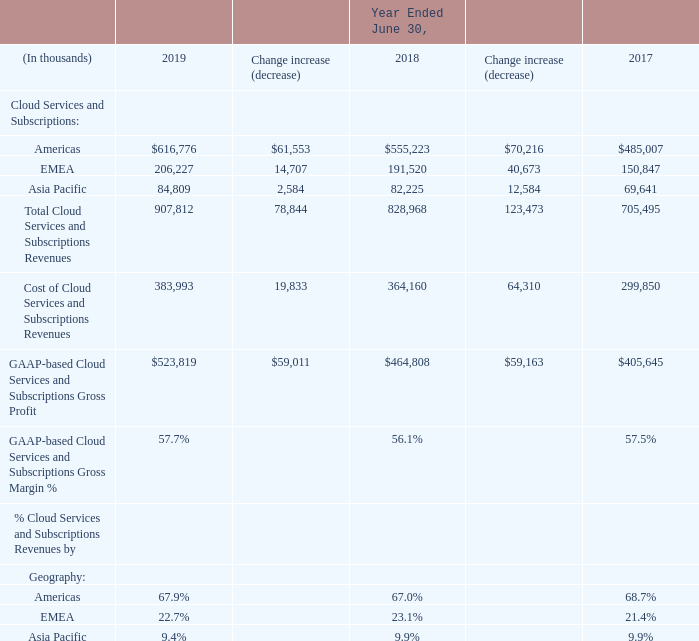2) Cloud Services and Subscriptions:
Cloud services and subscriptions revenues are from hosting arrangements where in connection with the licensing of software, the end user doesn’t take possession of the software, as well as from end-to-end fully outsourced business-to-business (B2B) integration solutions to our customers (collectively referred to as cloud arrangements). The software application resides on our hardware or that of a third party, and the customer accesses and uses the software on an as-needed basis via an identified line. Our cloud arrangements can be broadly categorized as "platform as a service" (PaaS), "software as a service" (SaaS), cloud subscriptions and managed services.
Cost of Cloud services and subscriptions revenues is comprised primarily of third party network usage fees, maintenance of in-house data hardware centers, technical support personnel-related costs, and some third party royalty costs.
Cloud services and subscriptions revenues increased by $78.8 million or 9.5% during the year ended June 30, 2019 as compared to the prior fiscal year; up 10.8% after factoring the impact of $10.8 million of foreign exchange rate changes. Geographically, the overall change was attributable to an increase in Americas of $61.6 million, an increase in EMEA of $14.7 million, and an increase in Asia Pacific of $2.6 million.
The number of Cloud services deals greater than $1.0 million that closed during Fiscal 2019 was 46 deals, consistent with that in Fiscal 2018.
Cost of Cloud services and subscriptions revenues increased by $19.8 million during the year ended June 30, 2019 as compared to the prior fiscal year, due to an increase in labour-related costs of approximately $19.1 million and an increase in third party network usage fees of $1.3 million. These were partially offset by a decrease in other miscellaneous costs of $0.6 million. The increase in labour-related costs was primarily due to increased headcount from recent acquisitions.
Overall, the gross margin percentage on Cloud services and subscriptions revenues increased to approximately 58% from approximately 56%.
For illustrative purposes only, had we accounted for revenues under proforma Topic 605, Cloud services and subscriptions revenues would have been $901.5 million for the year ended June 30, 2019, which would have been higher by approximately $72.5 million or 8.7% as compared to the prior fiscal year; and would have been up 10.1% after factoring the impact of $11.0 million of foreign exchange rate changes. Geographically, the overall change would have been attributable to an increase in Americas of $56.4 million, and an increase in EMEA of $12.4 million and an increase in Asia Pacific of $3.7 million.
The $6.4 million difference between cloud service and subscription revenues recognized under Topic 606 and those proforma Topic 605 cloud services and subscriptions revenues described above is primarily the result of timing differences on professional services related to cloud contracts, where under Topic 605, revenues would have been deferred over the estimated life of the contract, but under Topic 606 these revenues are recognized as services are performed. For more details, see note 3 "Revenues" to our Consolidated Financial Statements.
Where are Cloud services and subscriptions revenues from? Hosting arrangements where in connection with the licensing of software, the end user doesn’t take possession of the software, as well as from end-to-end fully outsourced business-to-business (b2b) integration solutions to our customers (collectively referred to as cloud arrangements). What is Cost of Cloud services and subscriptions revenues comprised primarily of? Third party network usage fees, maintenance of in-house data hardware centers, technical support personnel-related costs, and some third party royalty costs. What years are included in the table? 2019, 2018, 2017. What is the average GAAP-based Cloud Services and Subscriptions Gross Margin %?
Answer scale should be: percent. (57.7+56.1+57.5)/3
Answer: 57.1. What is the percentage increase in the Cloud Services and Subscriptions for Americas for 2018 to 2019?
Answer scale should be: percent. 61,553/555,223
Answer: 11.09. What is the average annual GAAP-based Cloud Services and Subscriptions Gross Profit for the 3 years?
Answer scale should be: thousand. (523,819+464,808+405,645)/3
Answer: 464757.33. 